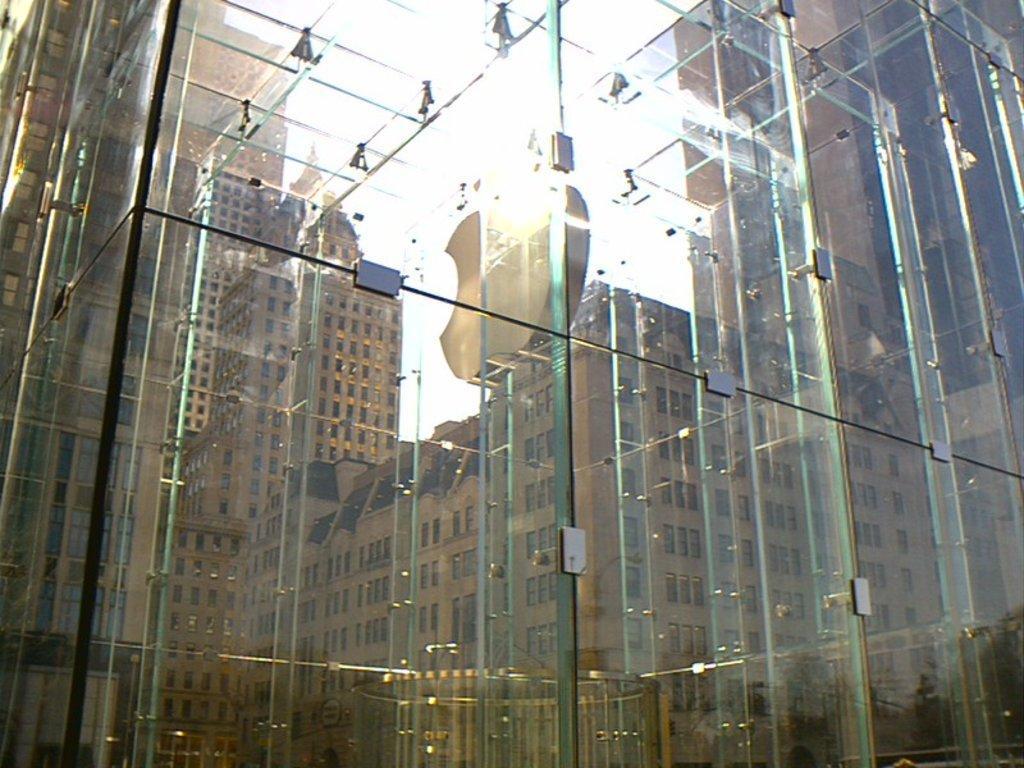Can you describe this image briefly? In this picture there is a building. There are reflections of buildings and there is a reflection of sky and vehicle and there are reflections of trees on the glass. Behind the glass there is a logo and there might be light. 